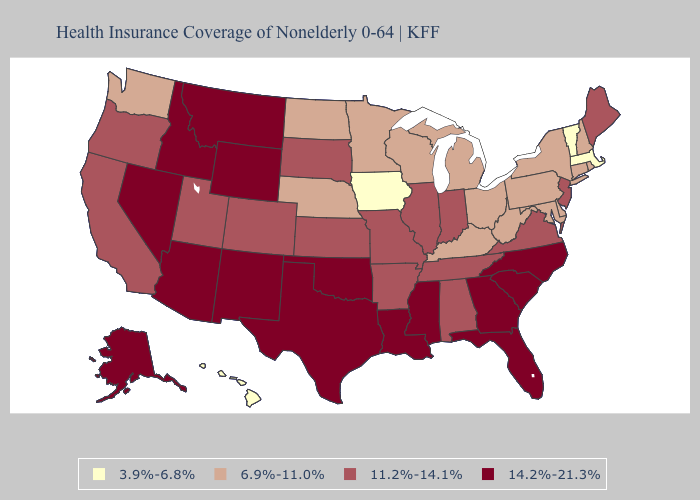What is the lowest value in states that border Louisiana?
Keep it brief. 11.2%-14.1%. Among the states that border Arizona , does Utah have the lowest value?
Give a very brief answer. Yes. Which states hav the highest value in the Northeast?
Quick response, please. Maine, New Jersey. Which states have the lowest value in the South?
Give a very brief answer. Delaware, Kentucky, Maryland, West Virginia. Among the states that border Louisiana , which have the highest value?
Write a very short answer. Mississippi, Texas. What is the value of Oregon?
Be succinct. 11.2%-14.1%. Among the states that border Virginia , which have the lowest value?
Write a very short answer. Kentucky, Maryland, West Virginia. Name the states that have a value in the range 6.9%-11.0%?
Quick response, please. Connecticut, Delaware, Kentucky, Maryland, Michigan, Minnesota, Nebraska, New Hampshire, New York, North Dakota, Ohio, Pennsylvania, Rhode Island, Washington, West Virginia, Wisconsin. Does the map have missing data?
Write a very short answer. No. What is the lowest value in the USA?
Give a very brief answer. 3.9%-6.8%. Name the states that have a value in the range 3.9%-6.8%?
Concise answer only. Hawaii, Iowa, Massachusetts, Vermont. How many symbols are there in the legend?
Answer briefly. 4. What is the value of Florida?
Concise answer only. 14.2%-21.3%. Among the states that border Idaho , does Wyoming have the lowest value?
Answer briefly. No. Which states have the highest value in the USA?
Give a very brief answer. Alaska, Arizona, Florida, Georgia, Idaho, Louisiana, Mississippi, Montana, Nevada, New Mexico, North Carolina, Oklahoma, South Carolina, Texas, Wyoming. 